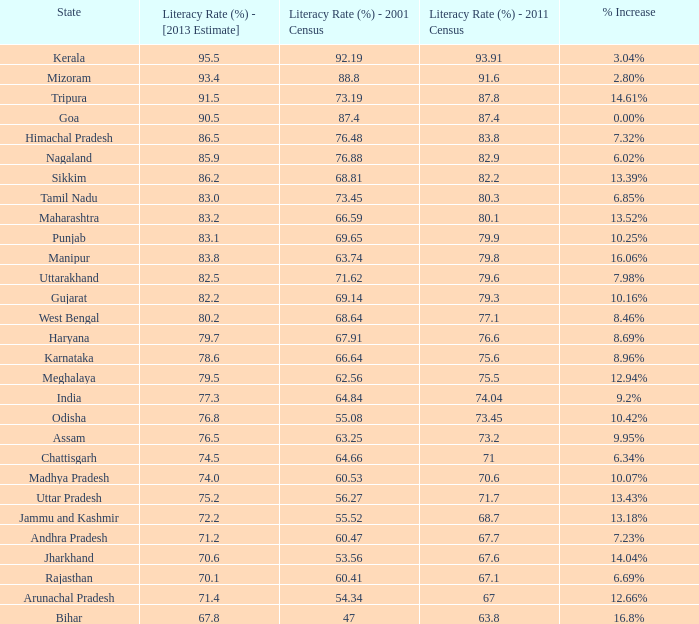What was the literacy rate published in the 2001 census for the state that saw a 12.66% increase? 54.34. 